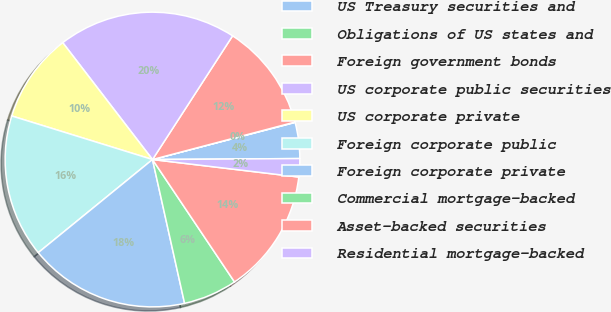Convert chart. <chart><loc_0><loc_0><loc_500><loc_500><pie_chart><fcel>US Treasury securities and<fcel>Obligations of US states and<fcel>Foreign government bonds<fcel>US corporate public securities<fcel>US corporate private<fcel>Foreign corporate public<fcel>Foreign corporate private<fcel>Commercial mortgage-backed<fcel>Asset-backed securities<fcel>Residential mortgage-backed<nl><fcel>3.95%<fcel>0.04%<fcel>11.76%<fcel>19.57%<fcel>9.8%<fcel>15.66%<fcel>17.61%<fcel>5.9%<fcel>13.71%<fcel>2.0%<nl></chart> 